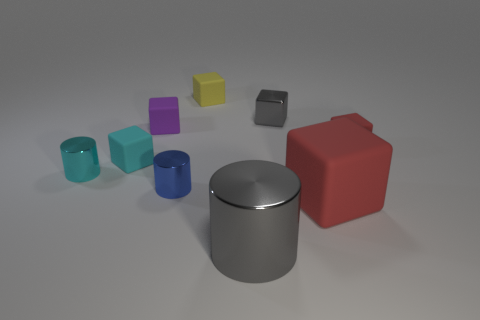Subtract all yellow cubes. How many cubes are left? 5 Subtract all small yellow rubber cubes. How many cubes are left? 5 Subtract all purple blocks. Subtract all green cylinders. How many blocks are left? 5 Add 1 brown metal objects. How many objects exist? 10 Subtract all cylinders. How many objects are left? 6 Subtract all large green rubber spheres. Subtract all small yellow rubber blocks. How many objects are left? 8 Add 9 tiny yellow rubber cubes. How many tiny yellow rubber cubes are left? 10 Add 6 purple cubes. How many purple cubes exist? 7 Subtract 0 green cubes. How many objects are left? 9 